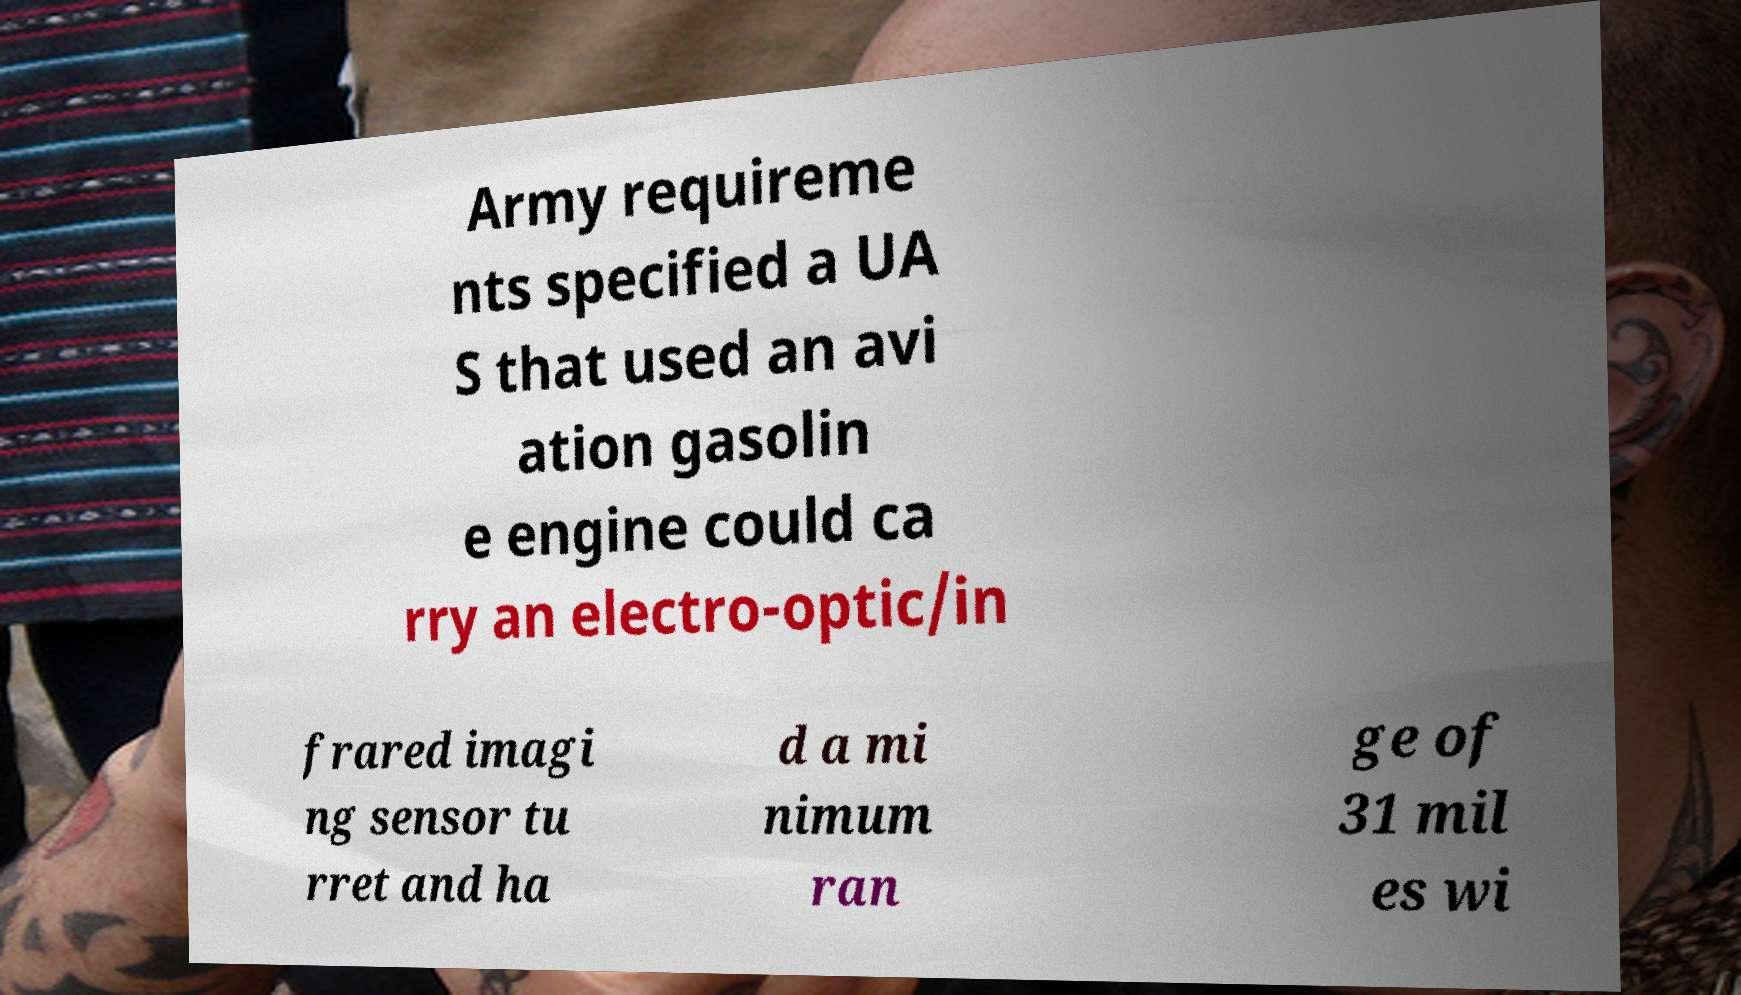I need the written content from this picture converted into text. Can you do that? Army requireme nts specified a UA S that used an avi ation gasolin e engine could ca rry an electro-optic/in frared imagi ng sensor tu rret and ha d a mi nimum ran ge of 31 mil es wi 